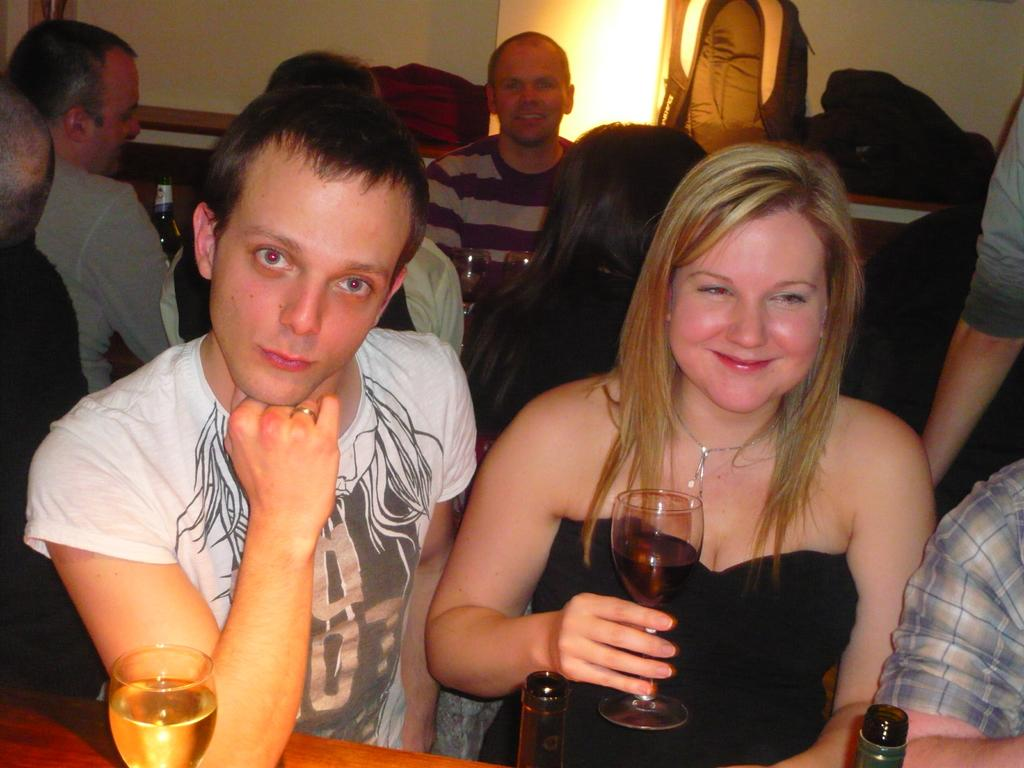How many people are in the image? There are multiple people in the image. What is the woman holding in the image? The woman is holding a glass. What expression does the woman have on her face? The woman has a smile on her face. What type of trade is being conducted at the border in the image? There is no mention of trade or a border in the image; it features multiple people, with a woman holding a glass and smiling. 